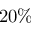Convert formula to latex. <formula><loc_0><loc_0><loc_500><loc_500>2 0 \%</formula> 